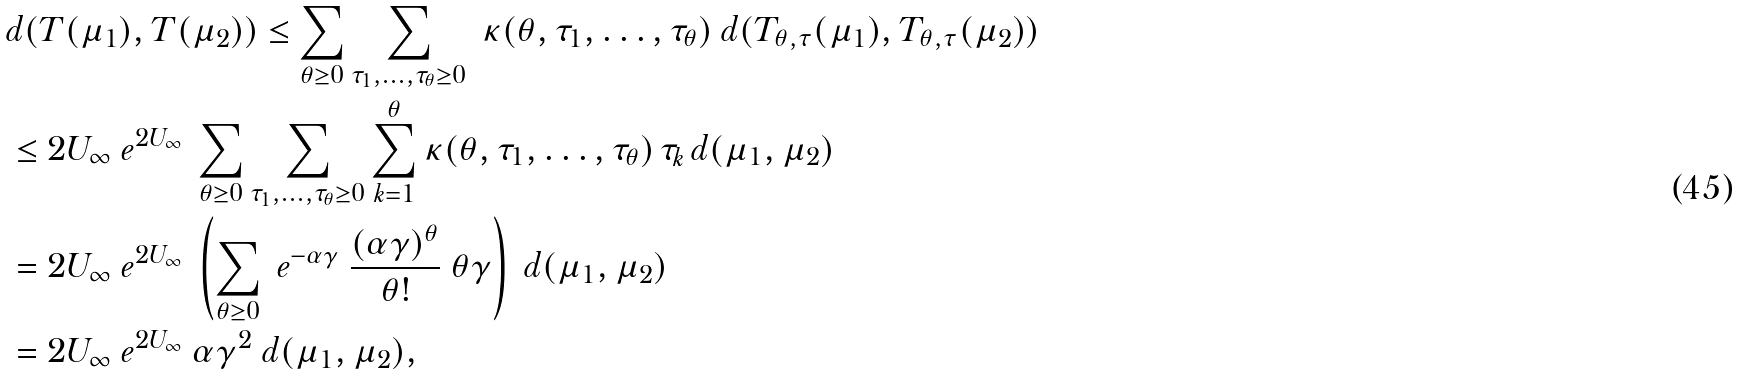<formula> <loc_0><loc_0><loc_500><loc_500>& d ( T ( \mu _ { 1 } ) , T ( \mu _ { 2 } ) ) \leq \sum _ { \theta \geq 0 } \sum _ { \tau _ { 1 } , \dots , \tau _ { \theta } \geq 0 } \ \kappa ( \theta , \tau _ { 1 } , \dots , \tau _ { \theta } ) \ d ( T _ { \theta , \tau } ( \mu _ { 1 } ) , T _ { \theta , \tau } ( \mu _ { 2 } ) ) \\ & \leq 2 U _ { \infty } \ e ^ { 2 U _ { \infty } } \ \sum _ { \theta \geq 0 } \sum _ { \tau _ { 1 } , \dots , \tau _ { \theta } \geq 0 } \sum _ { k = 1 } ^ { \theta } \kappa ( \theta , \tau _ { 1 } , \dots , \tau _ { \theta } ) \, \tau _ { k } \, d ( \mu _ { 1 } , \mu _ { 2 } ) \\ & = 2 U _ { \infty } \ e ^ { 2 U _ { \infty } } \ \left ( \sum _ { \theta \geq 0 } \ e ^ { - \alpha \gamma } \ \frac { ( \alpha \gamma ) ^ { \theta } } { \theta ! } \ \theta \gamma \right ) \ d ( \mu _ { 1 } , \mu _ { 2 } ) \\ & = 2 U _ { \infty } \ e ^ { 2 U _ { \infty } } \ \alpha \gamma ^ { 2 } \ d ( \mu _ { 1 } , \mu _ { 2 } ) ,</formula> 